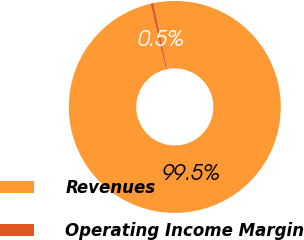Convert chart. <chart><loc_0><loc_0><loc_500><loc_500><pie_chart><fcel>Revenues<fcel>Operating Income Margin<nl><fcel>99.54%<fcel>0.46%<nl></chart> 